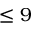Convert formula to latex. <formula><loc_0><loc_0><loc_500><loc_500>\leq 9</formula> 